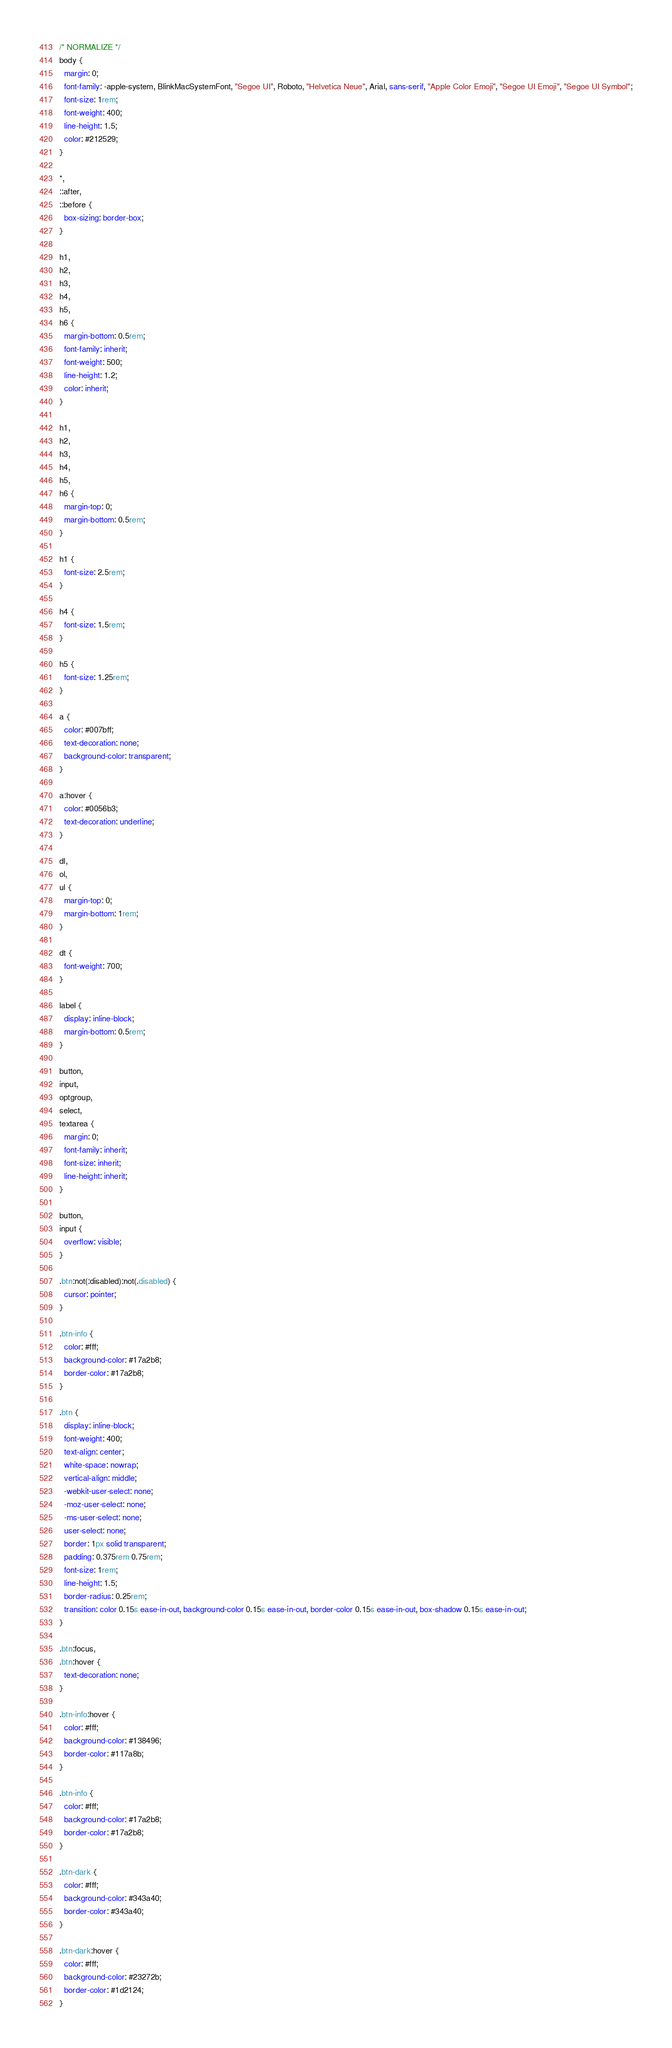Convert code to text. <code><loc_0><loc_0><loc_500><loc_500><_CSS_>/* NORMALIZE */
body {
  margin: 0;
  font-family: -apple-system, BlinkMacSystemFont, "Segoe UI", Roboto, "Helvetica Neue", Arial, sans-serif, "Apple Color Emoji", "Segoe UI Emoji", "Segoe UI Symbol";
  font-size: 1rem;
  font-weight: 400;
  line-height: 1.5;
  color: #212529;
}

*,
::after,
::before {
  box-sizing: border-box;
}

h1,
h2,
h3,
h4,
h5,
h6 {
  margin-bottom: 0.5rem;
  font-family: inherit;
  font-weight: 500;
  line-height: 1.2;
  color: inherit;
}

h1,
h2,
h3,
h4,
h5,
h6 {
  margin-top: 0;
  margin-bottom: 0.5rem;
}

h1 {
  font-size: 2.5rem;
}

h4 {
  font-size: 1.5rem;
}

h5 {
  font-size: 1.25rem;
}

a {
  color: #007bff;
  text-decoration: none;
  background-color: transparent;
}

a:hover {
  color: #0056b3;
  text-decoration: underline;
}

dl,
ol,
ul {
  margin-top: 0;
  margin-bottom: 1rem;
}

dt {
  font-weight: 700;
}

label {
  display: inline-block;
  margin-bottom: 0.5rem;
}

button,
input,
optgroup,
select,
textarea {
  margin: 0;
  font-family: inherit;
  font-size: inherit;
  line-height: inherit;
}

button,
input {
  overflow: visible;
}

.btn:not(:disabled):not(.disabled) {
  cursor: pointer;
}

.btn-info {
  color: #fff;
  background-color: #17a2b8;
  border-color: #17a2b8;
}

.btn {
  display: inline-block;
  font-weight: 400;
  text-align: center;
  white-space: nowrap;
  vertical-align: middle;
  -webkit-user-select: none;
  -moz-user-select: none;
  -ms-user-select: none;
  user-select: none;
  border: 1px solid transparent;
  padding: 0.375rem 0.75rem;
  font-size: 1rem;
  line-height: 1.5;
  border-radius: 0.25rem;
  transition: color 0.15s ease-in-out, background-color 0.15s ease-in-out, border-color 0.15s ease-in-out, box-shadow 0.15s ease-in-out;
}

.btn:focus,
.btn:hover {
  text-decoration: none;
}

.btn-info:hover {
  color: #fff;
  background-color: #138496;
  border-color: #117a8b;
}

.btn-info {
  color: #fff;
  background-color: #17a2b8;
  border-color: #17a2b8;
}

.btn-dark {
  color: #fff;
  background-color: #343a40;
  border-color: #343a40;
}

.btn-dark:hover {
  color: #fff;
  background-color: #23272b;
  border-color: #1d2124;
}
</code> 